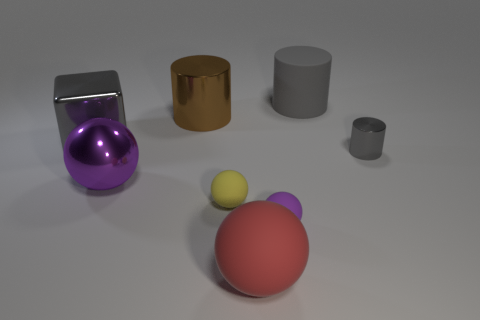There is a large object that is the same color as the rubber cylinder; what shape is it?
Provide a succinct answer. Cube. There is a cylinder that is right of the gray cylinder behind the gray shiny cylinder; what number of shiny objects are behind it?
Your response must be concise. 2. There is a cylinder that is the same size as the yellow matte object; what is its color?
Your response must be concise. Gray. What is the size of the matte ball on the right side of the large matte thing in front of the small gray metal thing?
Provide a succinct answer. Small. What size is the rubber cylinder that is the same color as the small shiny thing?
Provide a succinct answer. Large. What number of other objects are there of the same size as the brown metal cylinder?
Your answer should be very brief. 4. What number of tiny red rubber things are there?
Your response must be concise. 0. Does the red ball have the same size as the gray block?
Ensure brevity in your answer.  Yes. How many other things are the same shape as the yellow rubber thing?
Provide a short and direct response. 3. What is the gray object behind the gray thing to the left of the red ball made of?
Your answer should be very brief. Rubber. 